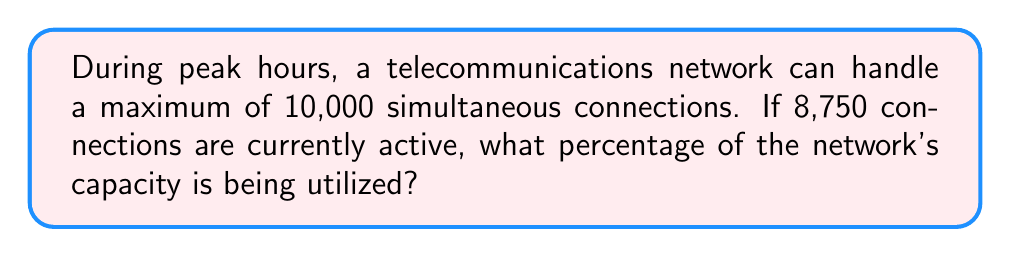Could you help me with this problem? To determine the percentage of network capacity being utilized, we need to follow these steps:

1. Identify the given information:
   - Maximum capacity: 10,000 connections
   - Current active connections: 8,750

2. Set up the percentage calculation:
   Percentage = (Part / Whole) × 100

3. Plug in the values:
   Percentage = (8,750 / 10,000) × 100

4. Simplify the fraction:
   Percentage = 0.875 × 100

5. Perform the multiplication:
   Percentage = 87.5

Therefore, the network is utilizing 87.5% of its capacity during peak hours.
Answer: 87.5% 